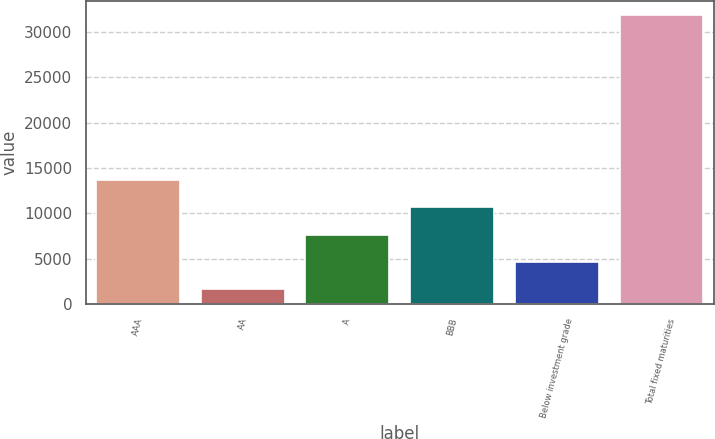Convert chart to OTSL. <chart><loc_0><loc_0><loc_500><loc_500><bar_chart><fcel>AAA<fcel>AA<fcel>A<fcel>BBB<fcel>Below investment grade<fcel>Total fixed maturities<nl><fcel>13692.8<fcel>1616<fcel>7654.4<fcel>10673.6<fcel>4635.2<fcel>31808<nl></chart> 